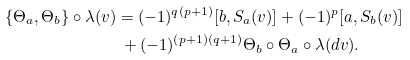<formula> <loc_0><loc_0><loc_500><loc_500>\{ \Theta _ { a } , \Theta _ { b } \} \circ \lambda ( v ) & = ( - 1 ) ^ { q ( p + 1 ) } [ b , S _ { a } ( v ) ] + ( - 1 ) ^ { p } [ a , S _ { b } ( v ) ] \\ & \ + ( - 1 ) ^ { ( p + 1 ) ( q + 1 ) } \Theta _ { b } \circ \Theta _ { a } \circ \lambda ( d v ) .</formula> 